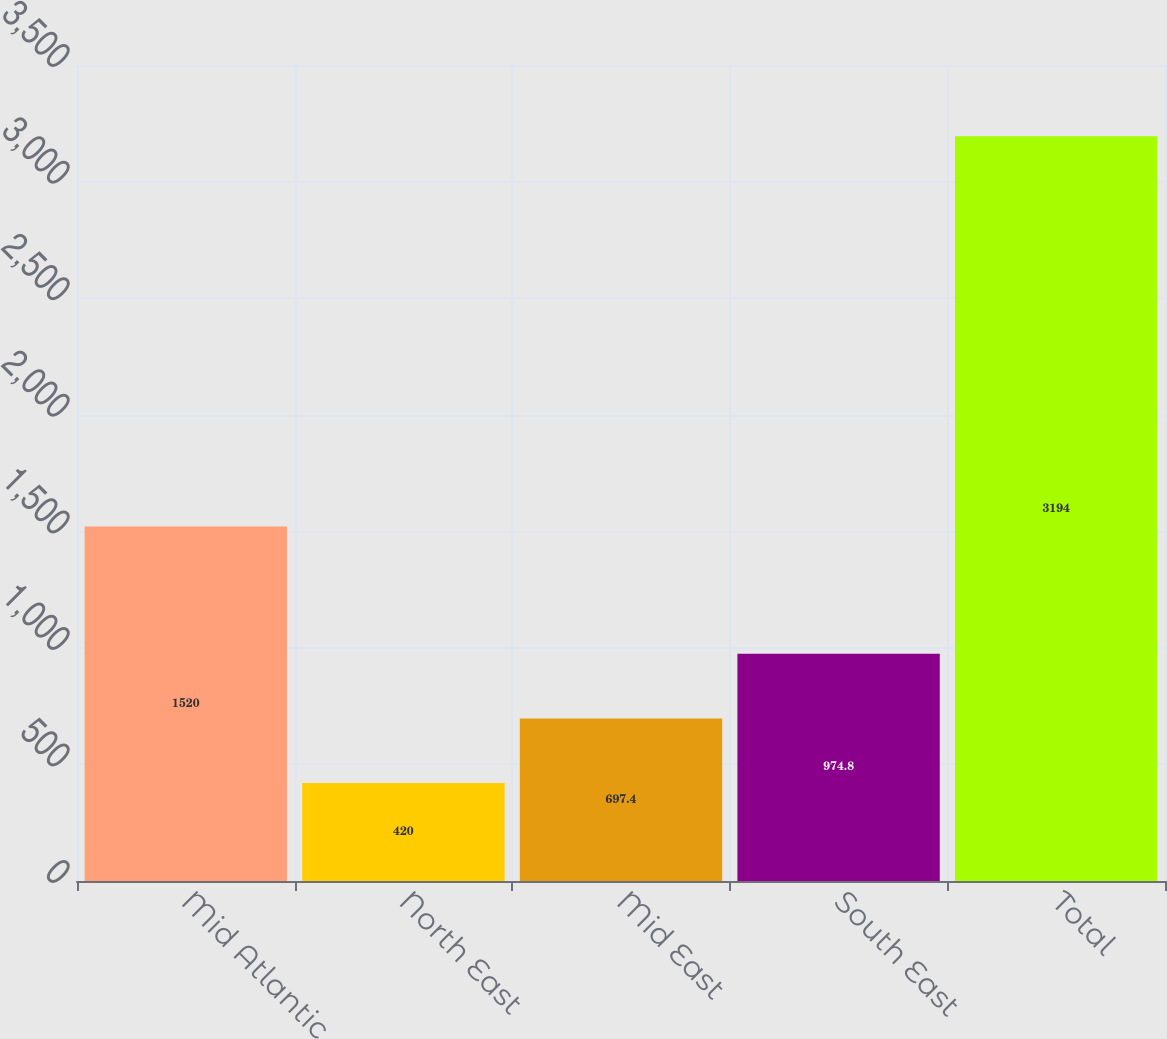<chart> <loc_0><loc_0><loc_500><loc_500><bar_chart><fcel>Mid Atlantic<fcel>North East<fcel>Mid East<fcel>South East<fcel>Total<nl><fcel>1520<fcel>420<fcel>697.4<fcel>974.8<fcel>3194<nl></chart> 